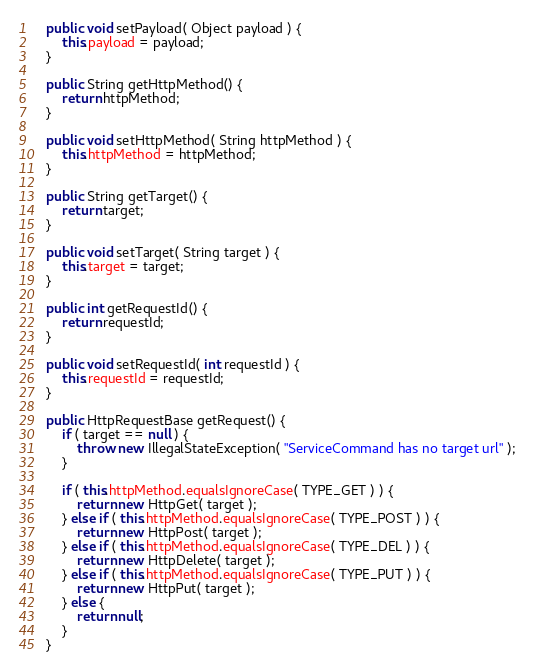Convert code to text. <code><loc_0><loc_0><loc_500><loc_500><_Java_>    public void setPayload( Object payload ) {
        this.payload = payload;
    }

    public String getHttpMethod() {
        return httpMethod;
    }

    public void setHttpMethod( String httpMethod ) {
        this.httpMethod = httpMethod;
    }

    public String getTarget() {
        return target;
    }

    public void setTarget( String target ) {
        this.target = target;
    }

    public int getRequestId() {
        return requestId;
    }

    public void setRequestId( int requestId ) {
        this.requestId = requestId;
    }

    public HttpRequestBase getRequest() {
        if ( target == null ) {
            throw new IllegalStateException( "ServiceCommand has no target url" );
        }

        if ( this.httpMethod.equalsIgnoreCase( TYPE_GET ) ) {
            return new HttpGet( target );
        } else if ( this.httpMethod.equalsIgnoreCase( TYPE_POST ) ) {
            return new HttpPost( target );
        } else if ( this.httpMethod.equalsIgnoreCase( TYPE_DEL ) ) {
            return new HttpDelete( target );
        } else if ( this.httpMethod.equalsIgnoreCase( TYPE_PUT ) ) {
            return new HttpPut( target );
        } else {
            return null;
        }
    }
</code> 